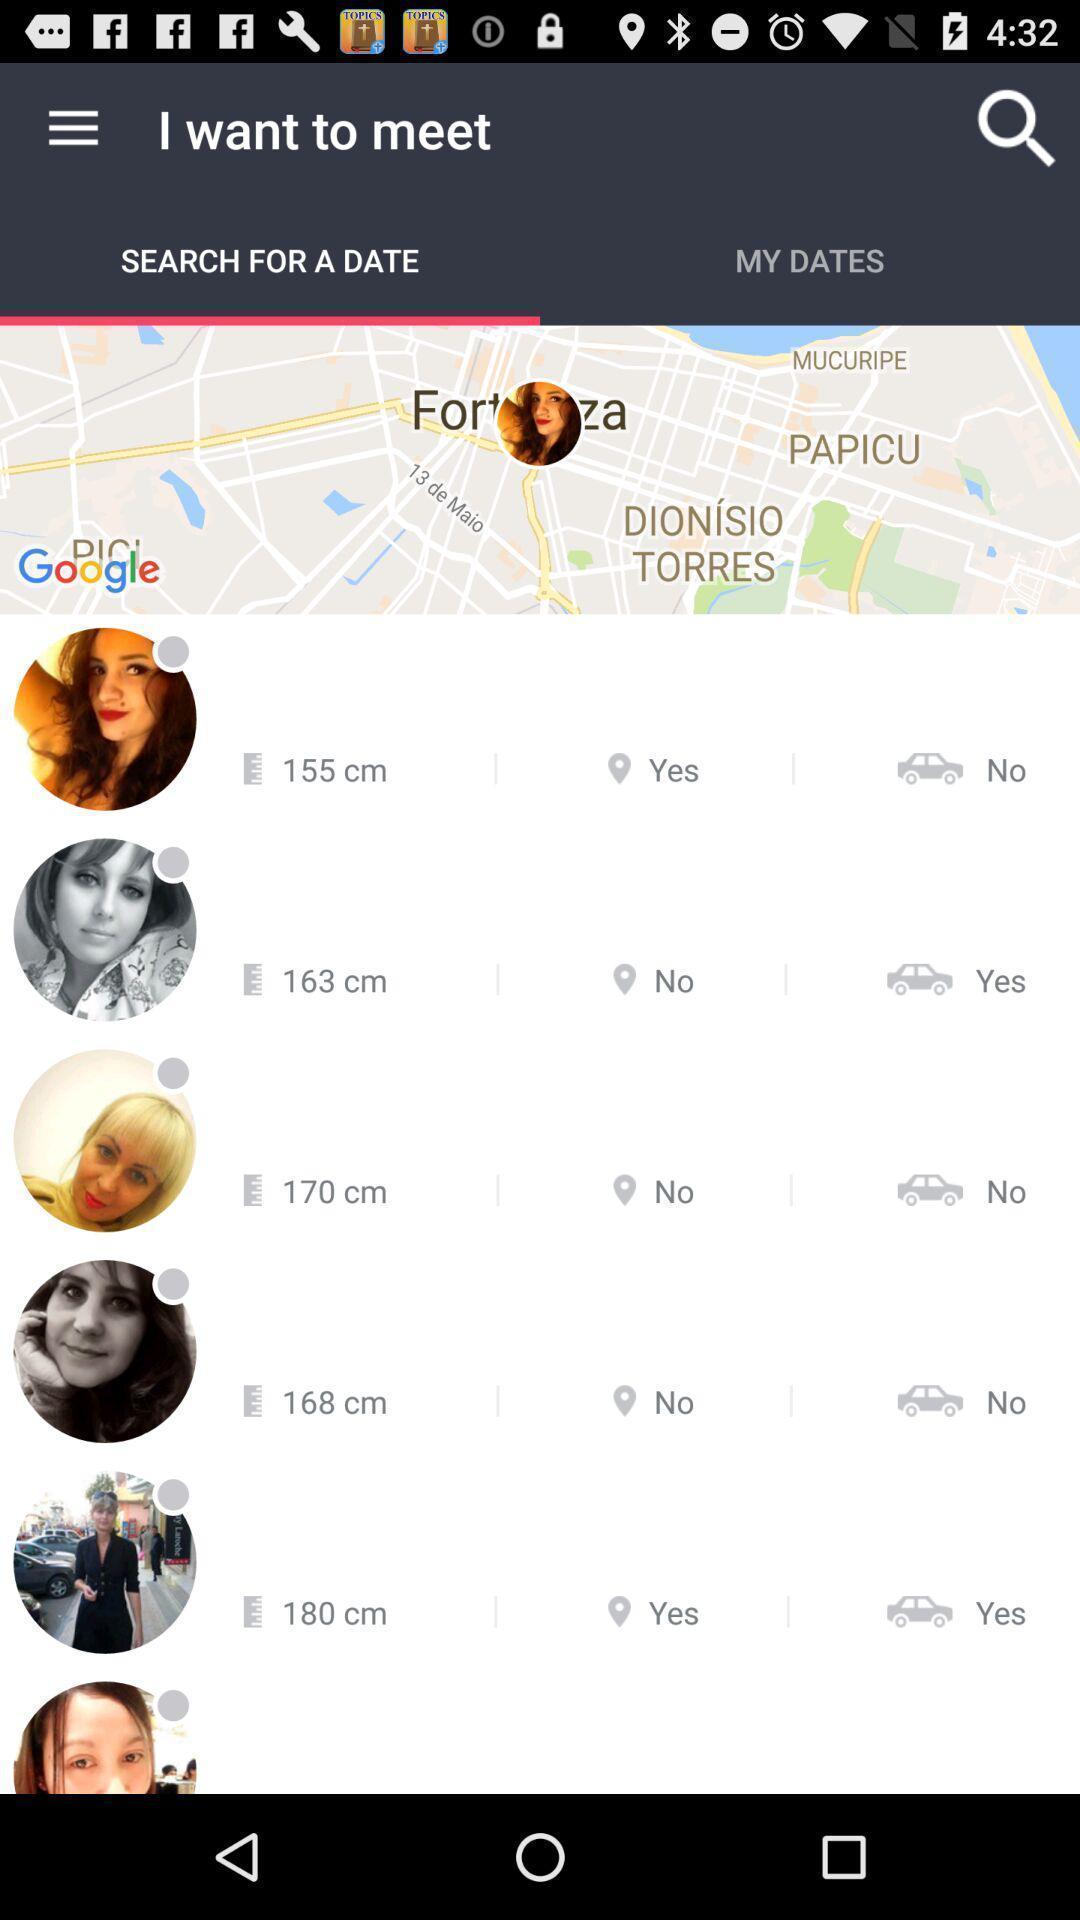Summarize the information in this screenshot. Page is about a dating app. 